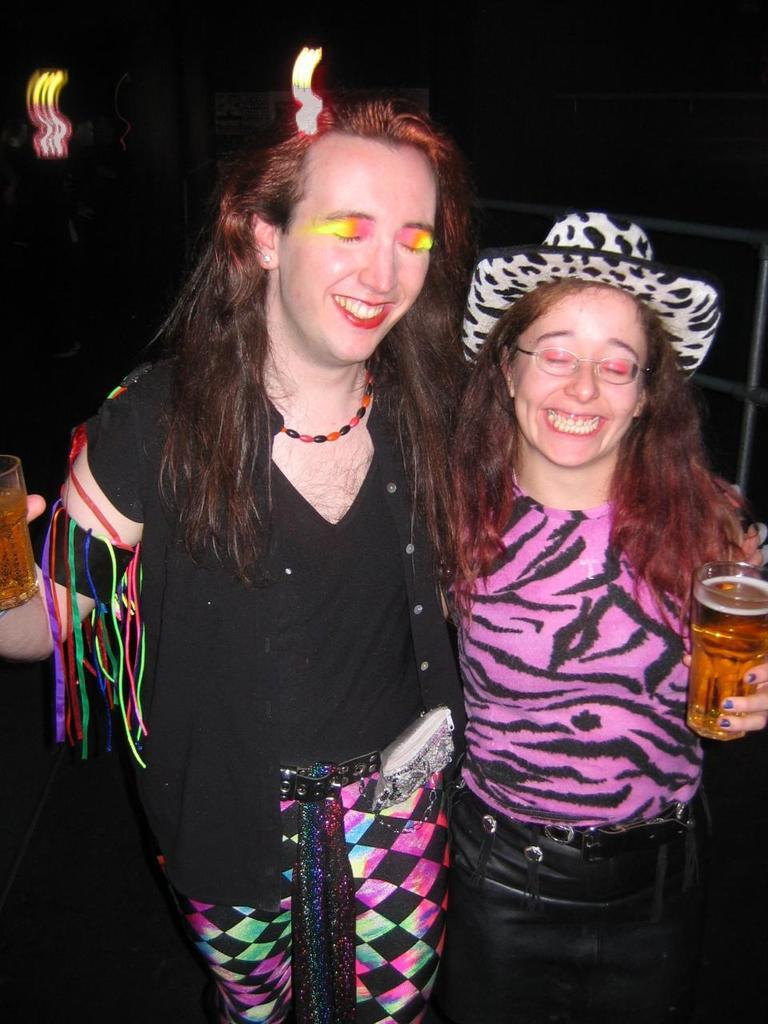How many people are in the image? There are two women in the image. What are the women holding in their hands? The women are holding glasses. What type of architectural feature can be seen in the image? There are iron grilles visible in the image. What is the color of the background in the image? The background of the image is dark. What type of knee injury can be seen in the image? There is no knee injury present in the image; it features two women holding glasses. What shocking event is depicted in the image? There is no shocking event depicted in the image; it shows two women holding glasses with a dark background and iron grilles. 